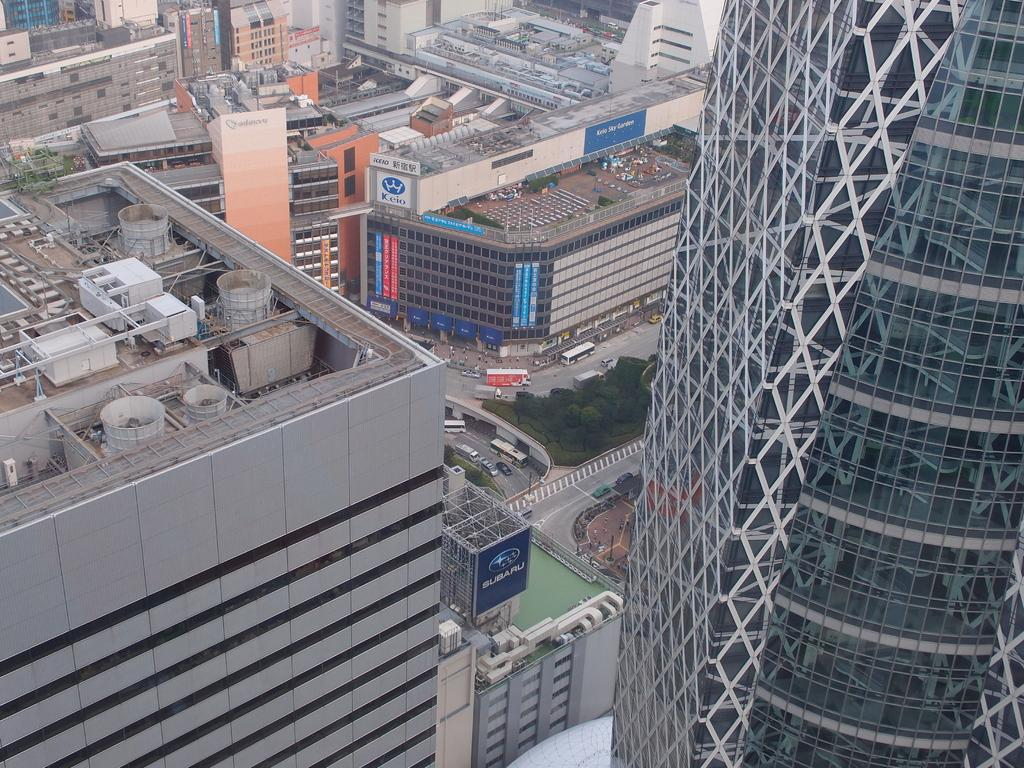What type of structures can be seen in the image? There are buildings in the image. What other objects can be seen in the image besides buildings? There are boards, trees, vehicles on the road, and other objects in the image. How many bulbs are hanging from the trees in the image? There are no bulbs hanging from the trees in the image. Can you see any deer in the image? There are no deer present in the image. 